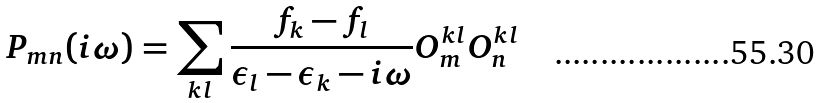Convert formula to latex. <formula><loc_0><loc_0><loc_500><loc_500>P _ { m n } ( i \omega ) = \sum _ { k l } \frac { f _ { k } - f _ { l } } { \epsilon _ { l } - \epsilon _ { k } - i \omega } O _ { m } ^ { k l } O _ { n } ^ { k l }</formula> 